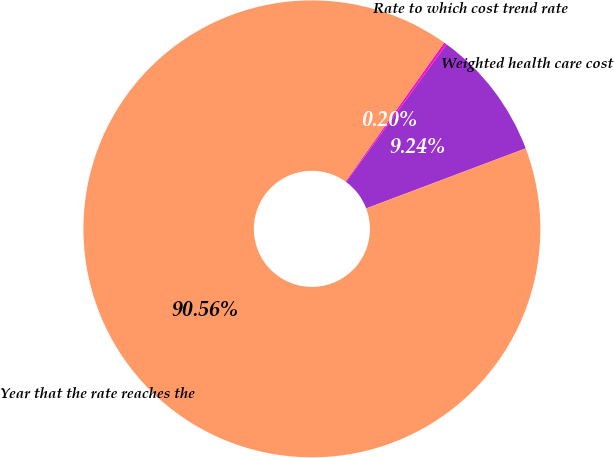<chart> <loc_0><loc_0><loc_500><loc_500><pie_chart><fcel>Weighted health care cost<fcel>Rate to which cost trend rate<fcel>Year that the rate reaches the<nl><fcel>9.24%<fcel>0.2%<fcel>90.56%<nl></chart> 